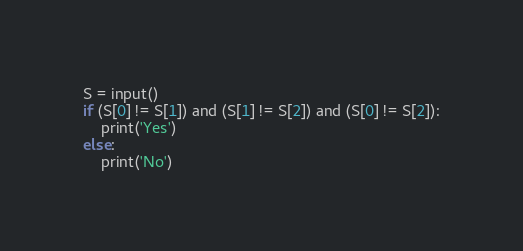Convert code to text. <code><loc_0><loc_0><loc_500><loc_500><_Python_>S = input()
if (S[0] != S[1]) and (S[1] != S[2]) and (S[0] != S[2]):
    print('Yes')
else:
    print('No')
</code> 